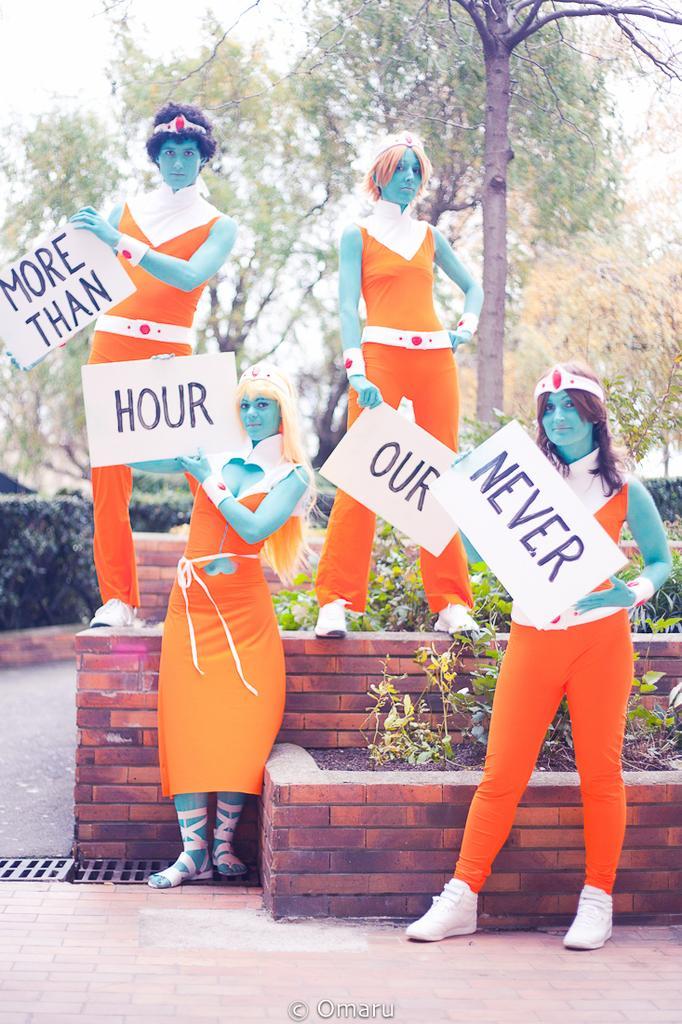How would you summarize this image in a sentence or two? In this picture we can see a group of people standing,they are holding posters and in the background we can see trees,sky. 